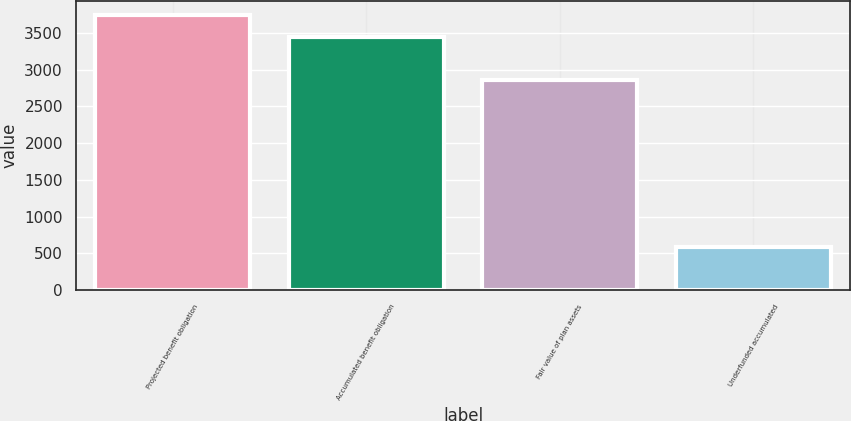Convert chart to OTSL. <chart><loc_0><loc_0><loc_500><loc_500><bar_chart><fcel>Projected benefit obligation<fcel>Accumulated benefit obligation<fcel>Fair value of plan assets<fcel>Underfunded accumulated<nl><fcel>3739.1<fcel>3440<fcel>2857<fcel>583<nl></chart> 